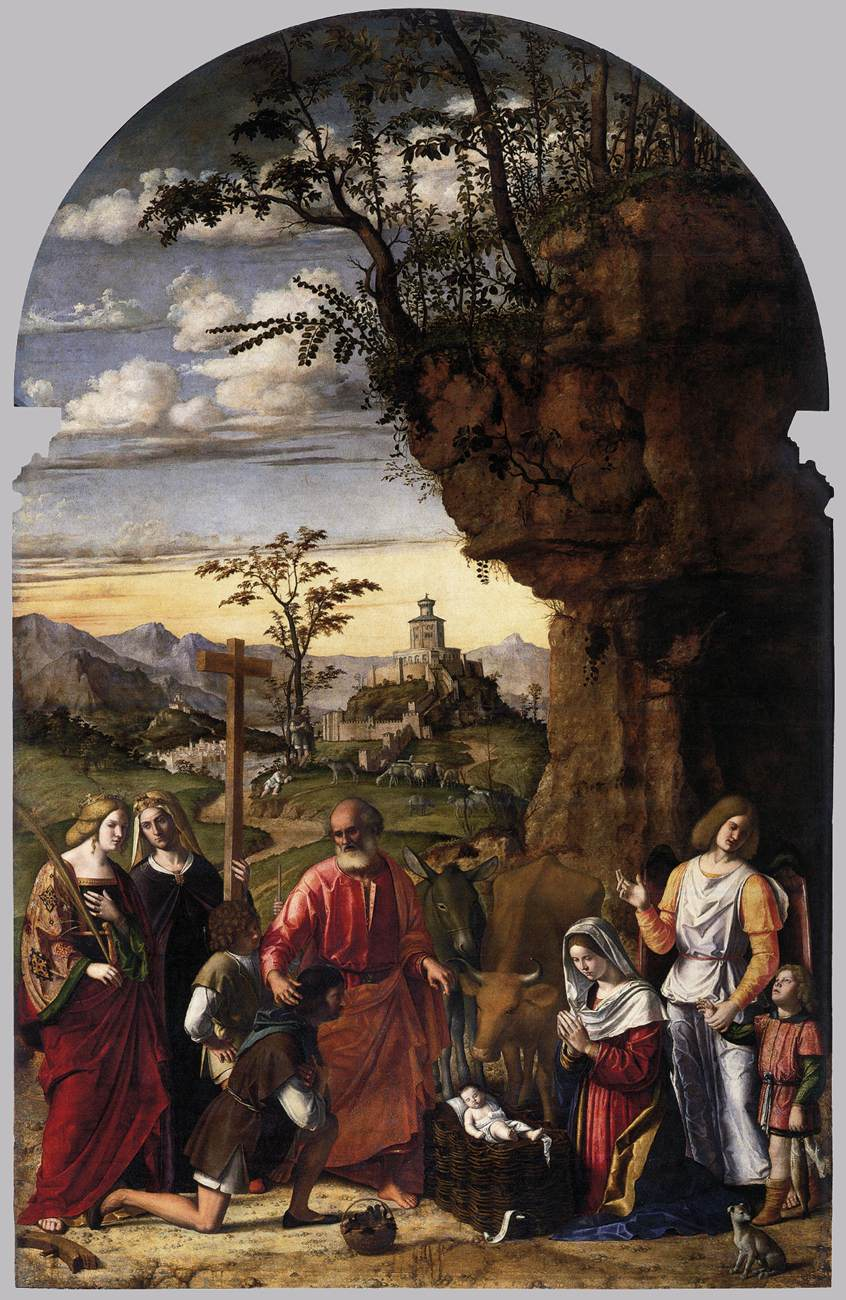Describe how modern technology might alter this scene if it were set in today's era. In a modern retelling, the Nativity scene could be set within an urban landscape, with neon lights and skyscrapers framing the scene. The figures might wear contemporary clothing, with Mary in a simple yet elegant dress and Joseph in modern-day attire. The Christ Child could be swaddled in a stylish infant blanket, lying in a hospital bassinet. Instead of shepherds, there might be people from various professions – perhaps a doctor, a teacher, or even a barista, emphasizing the universality of the event. Angelic figures might manifest through holographic projections, adding a futuristic touch, while smartphones and cameras could capture the moment, sharing it instantly across social media platforms. 